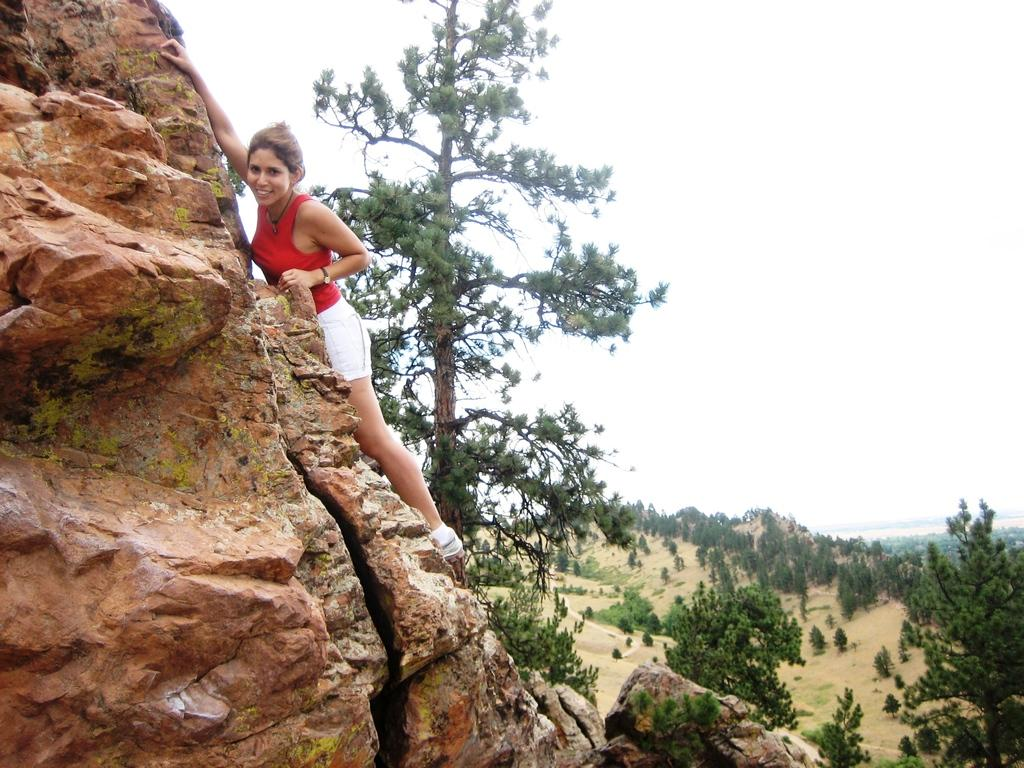What can be seen in the background of the image? There is a sky and trees visible in the background of the image. What is the woman on the left side of the image doing? The woman appears to be climbing a mountain. Can you describe the setting of the image? The image is set against a background of sky and trees, and the woman is climbing a mountain. What type of vest is the woman wearing in the image? There is no vest visible in the image; the woman is wearing clothing appropriate for climbing a mountain. 